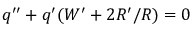<formula> <loc_0><loc_0><loc_500><loc_500>q ^ { \prime \prime } + q ^ { \prime } ( W ^ { \prime } + 2 R ^ { \prime } / R ) = 0</formula> 